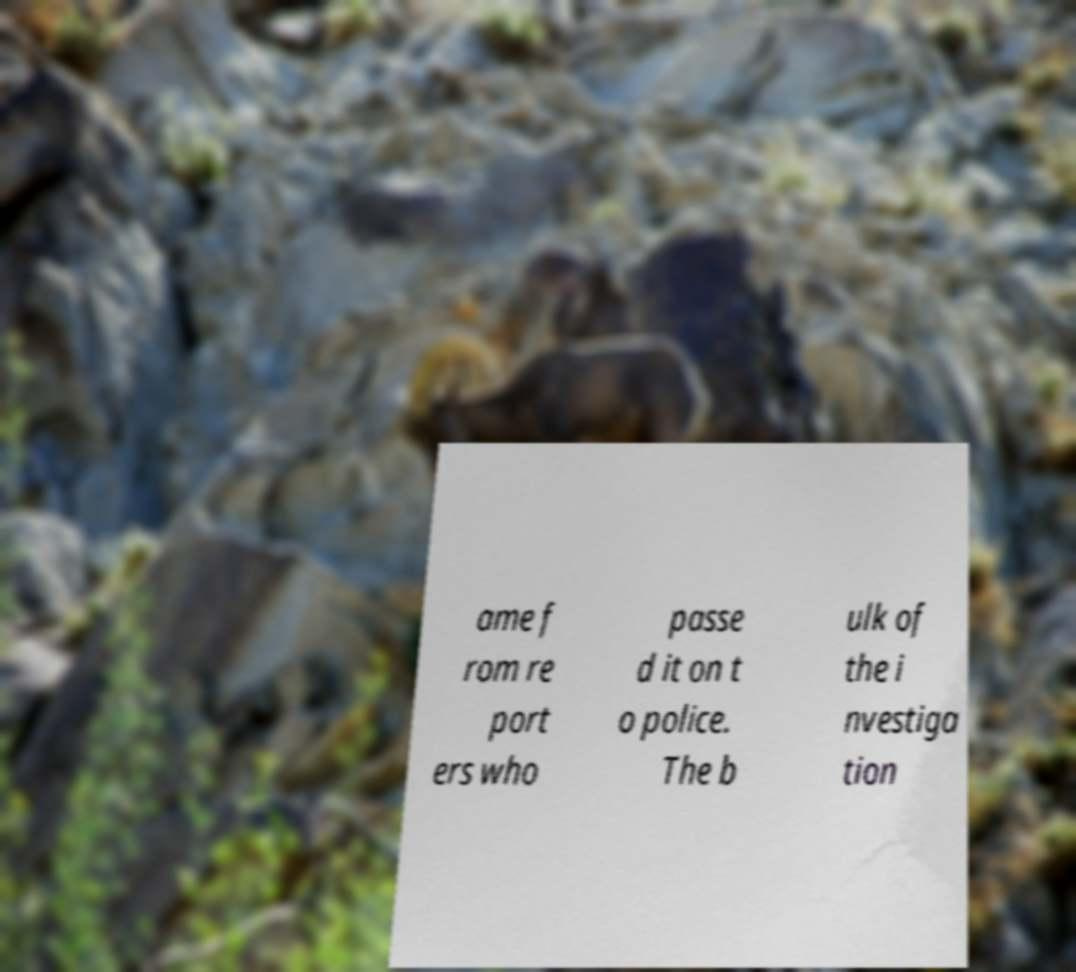There's text embedded in this image that I need extracted. Can you transcribe it verbatim? ame f rom re port ers who passe d it on t o police. The b ulk of the i nvestiga tion 